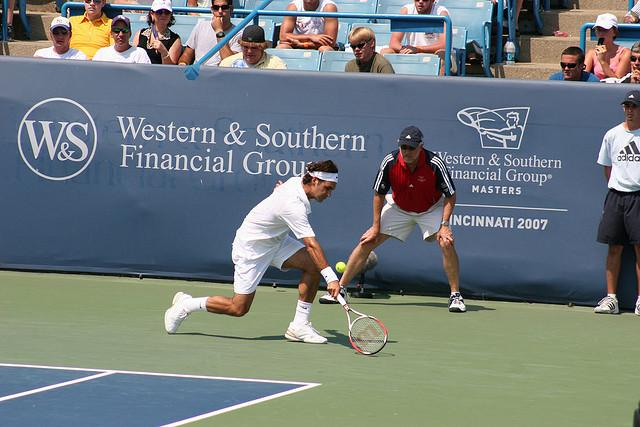When was the advertised company founded? Please explain your reasoning. 1888. It is western & southern financial group 